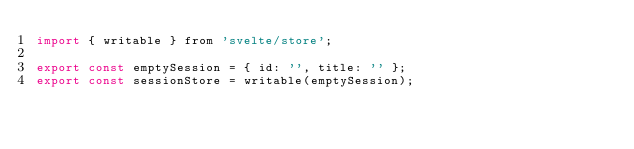<code> <loc_0><loc_0><loc_500><loc_500><_JavaScript_>import { writable } from 'svelte/store';

export const emptySession = { id: '', title: '' };
export const sessionStore = writable(emptySession);
</code> 